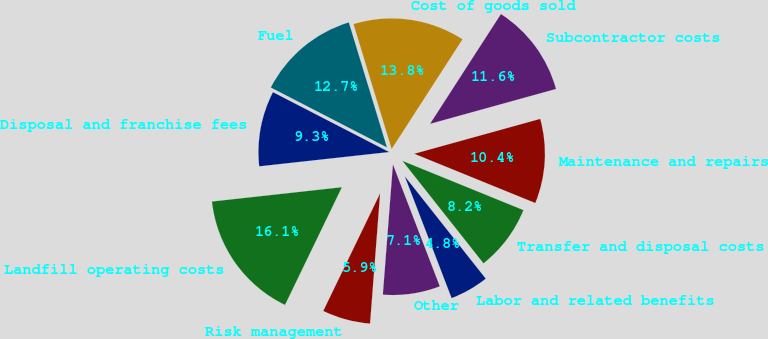<chart> <loc_0><loc_0><loc_500><loc_500><pie_chart><fcel>Labor and related benefits<fcel>Transfer and disposal costs<fcel>Maintenance and repairs<fcel>Subcontractor costs<fcel>Cost of goods sold<fcel>Fuel<fcel>Disposal and franchise fees<fcel>Landfill operating costs<fcel>Risk management<fcel>Other<nl><fcel>4.81%<fcel>8.2%<fcel>10.45%<fcel>11.58%<fcel>13.84%<fcel>12.71%<fcel>9.32%<fcel>16.09%<fcel>5.94%<fcel>7.07%<nl></chart> 